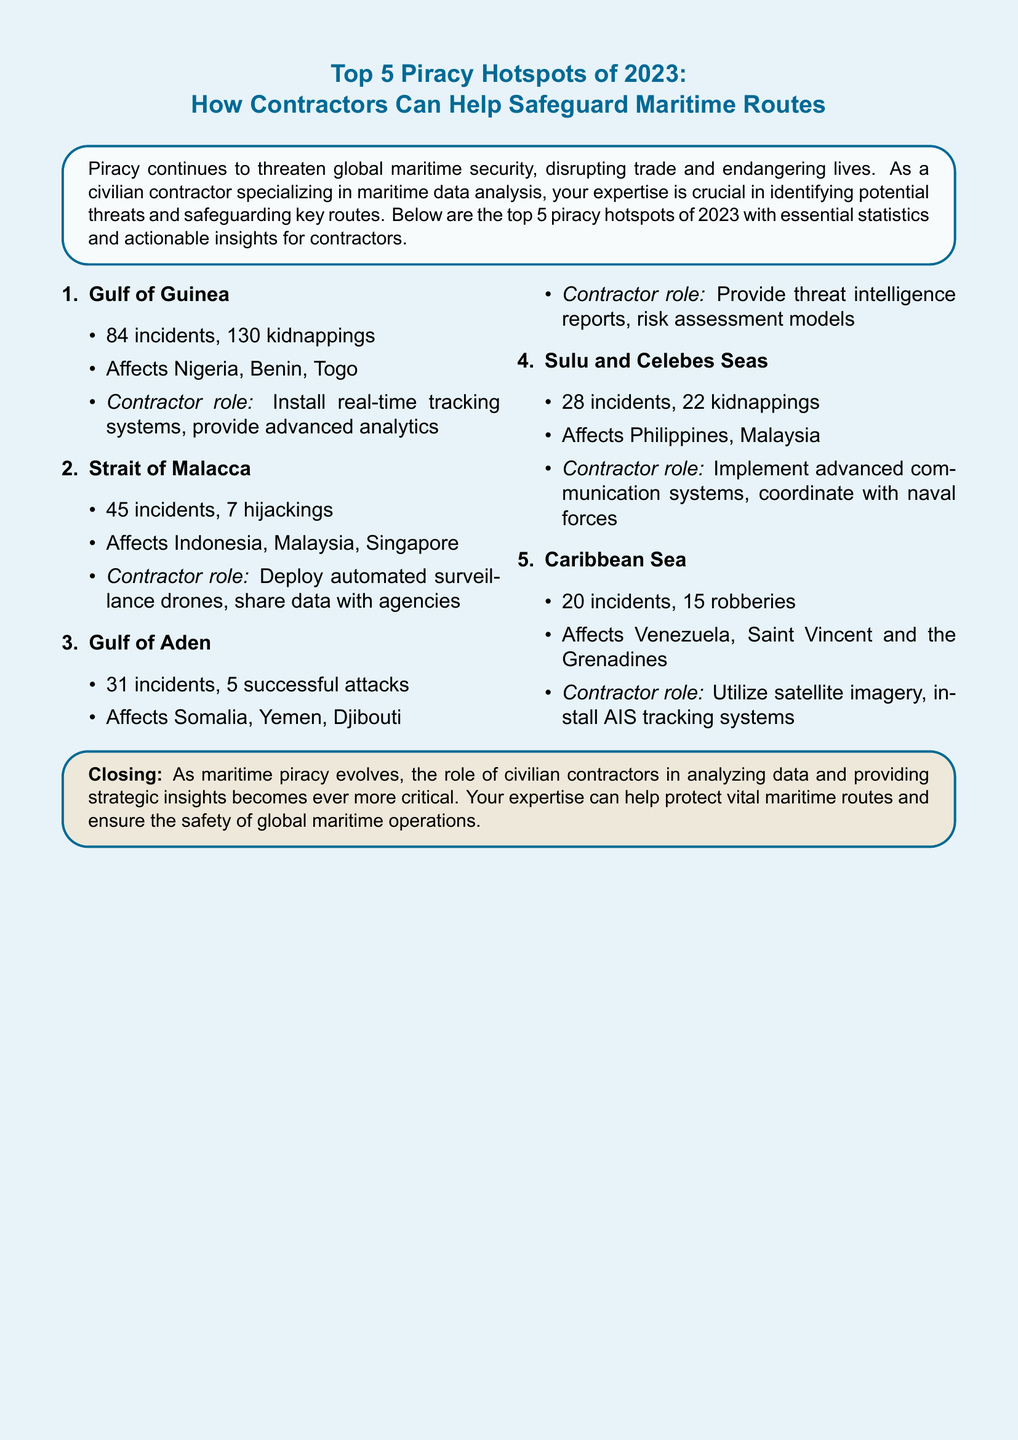What are the top 5 piracy hotspots of 2023? The document lists the Gulf of Guinea, Strait of Malacca, Gulf of Aden, Sulu and Celebes Seas, and Caribbean Sea as the top 5 piracy hotspots of 2023.
Answer: Gulf of Guinea, Strait of Malacca, Gulf of Aden, Sulu and Celebes Seas, Caribbean Sea How many incidents occurred in the Gulf of Guinea? The document states that there were 84 incidents in the Gulf of Guinea.
Answer: 84 incidents What is the number of kidnappings reported in the Gulf of Guinea? The document specifies that there were 130 kidnappings in the Gulf of Guinea.
Answer: 130 kidnappings What security role is suggested for contractors in the Strait of Malacca? The document suggests deploying automated surveillance drones and sharing data with agencies as the contractor's role in the Strait of Malacca.
Answer: Deploy automated surveillance drones, share data with agencies Which region reported the least number of piracy incidents? The document indicates that the Caribbean Sea reported 20 incidents, which is the least among the listed hotspots.
Answer: Caribbean Sea What percentage of incidents in the Sulu and Celebes Seas involved kidnappings? The document indicates there were 28 incidents and 22 kidnappings in the Sulu and Celebes Seas, thus calculating the percentage gives approximately 78.57%.
Answer: 78.57% What role can contractors play in the Gulf of Aden? The document mentions providing threat intelligence reports and risk assessment models as the contractor's role in the Gulf of Aden.
Answer: Provide threat intelligence reports, risk assessment models How many incidents occurred in the Caribbean Sea? The document lists 20 incidents in the Caribbean Sea.
Answer: 20 incidents What is the total number of reported incidents across all hotspots? The document totals the reported incidents: 84 (Gulf of Guinea) + 45 (Strait of Malacca) + 31 (Gulf of Aden) + 28 (Sulu and Celebes Seas) + 20 (Caribbean Sea) = 208 incidents.
Answer: 208 incidents 